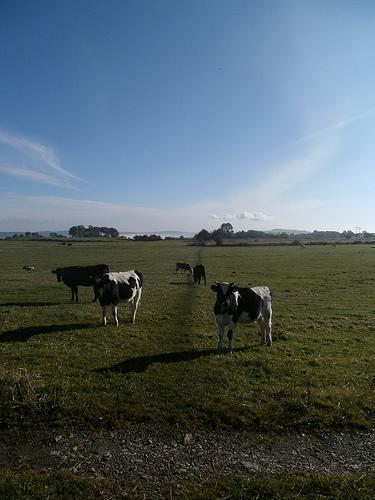How many horns does the bull have?
Give a very brief answer. 2. How many cows are laying down?
Give a very brief answer. 1. 